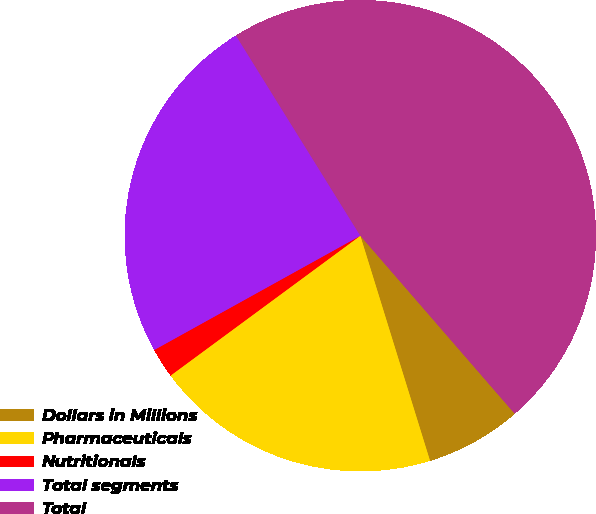<chart> <loc_0><loc_0><loc_500><loc_500><pie_chart><fcel>Dollars in Millions<fcel>Pharmaceuticals<fcel>Nutritionals<fcel>Total segments<fcel>Total<nl><fcel>6.59%<fcel>19.67%<fcel>2.05%<fcel>24.21%<fcel>47.47%<nl></chart> 